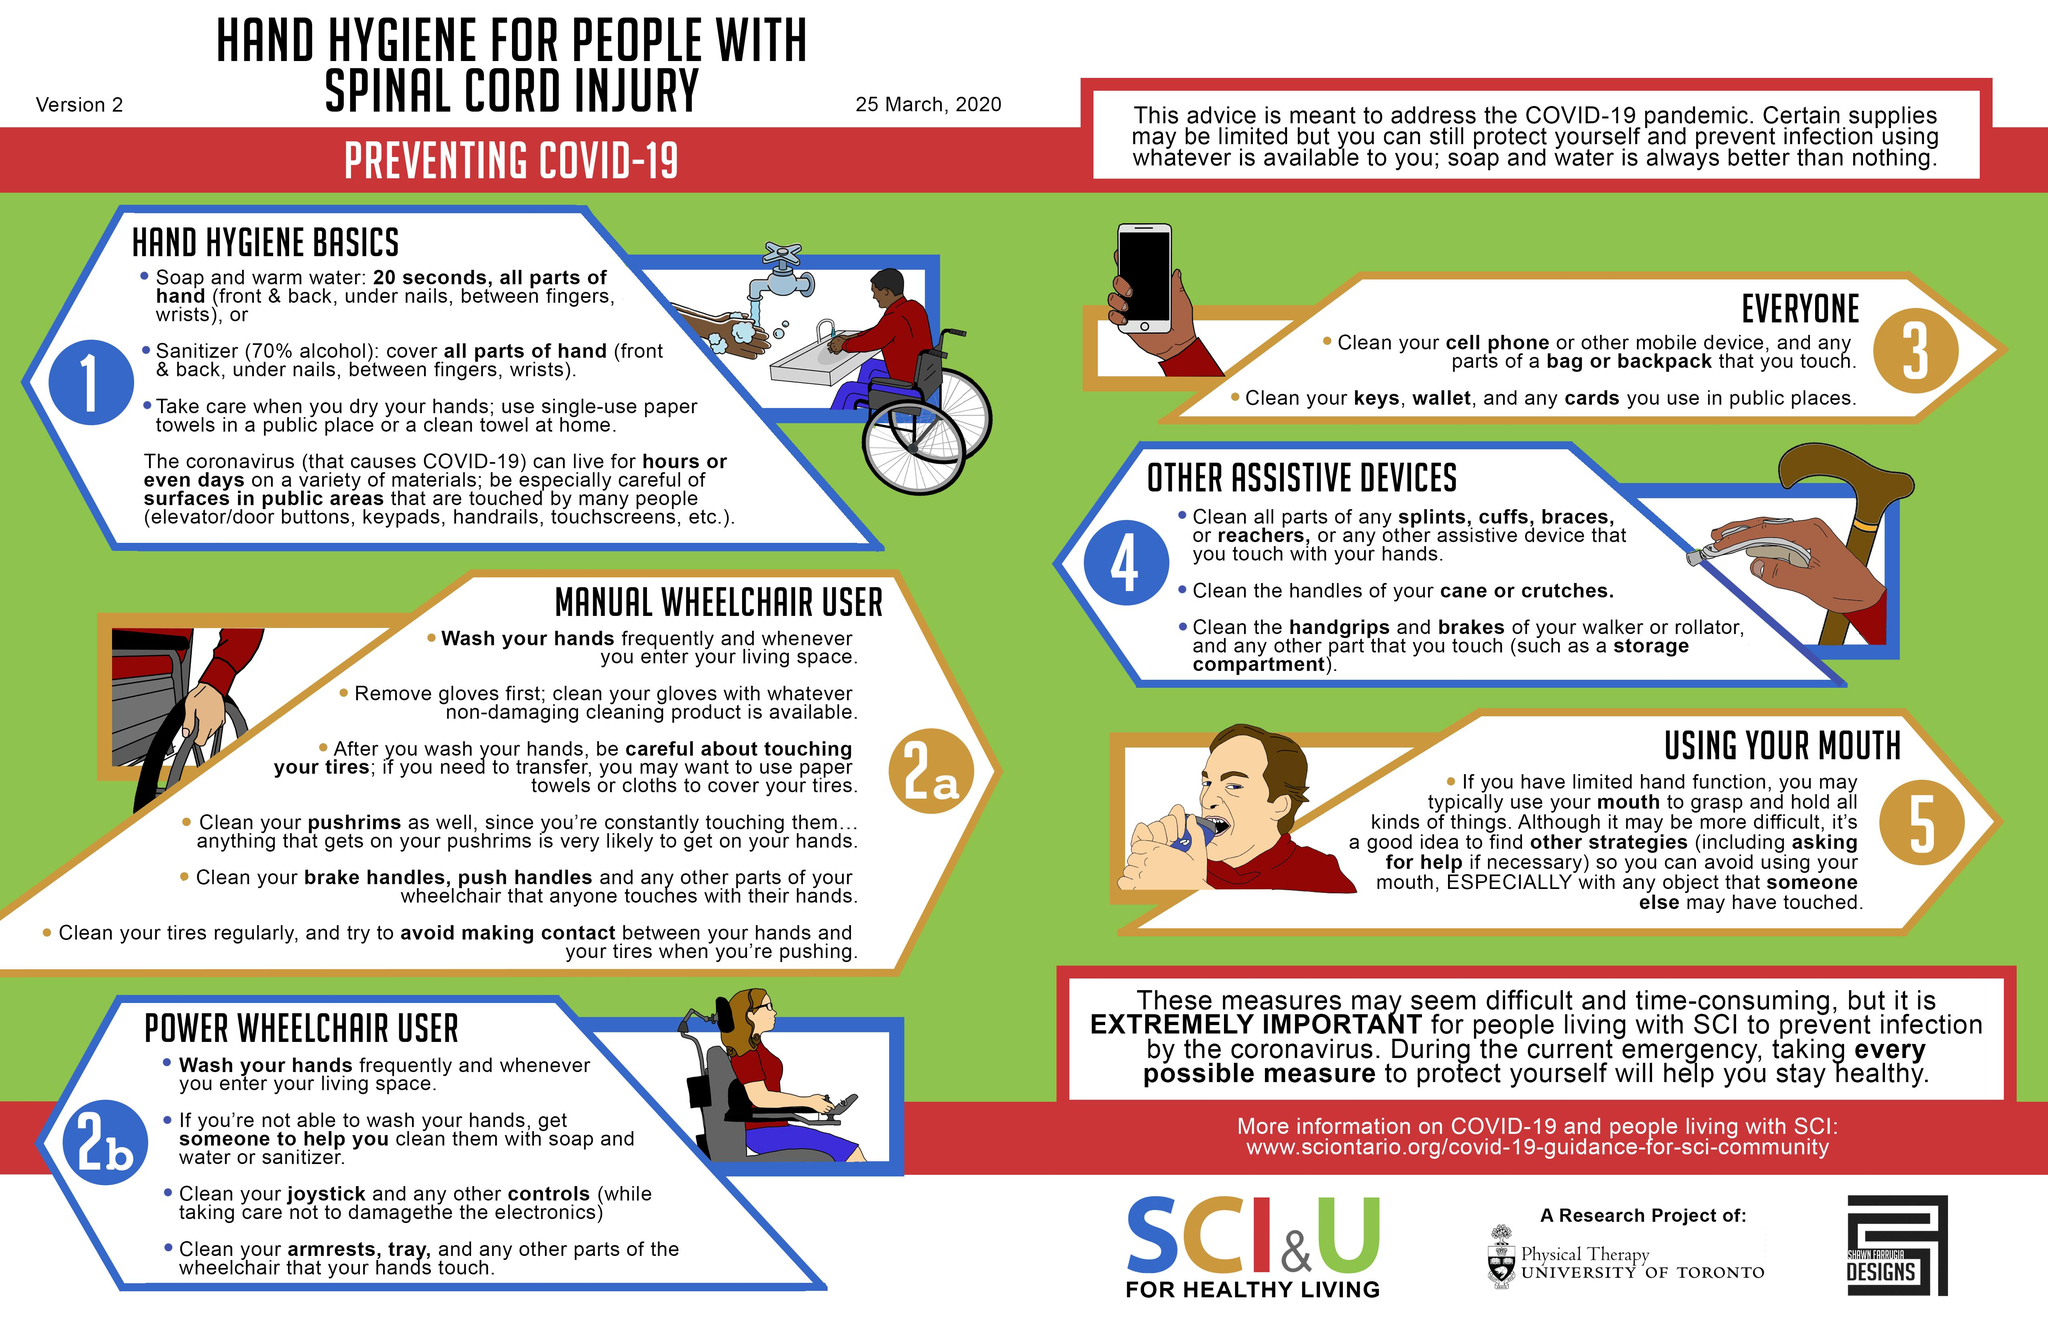Point out several critical features in this image. How many bullet points are there under "other assistive devices"? There are 3 of them. The power wheelchair contains electronic components that require regular cleaning, specifically the joystick and control buttons. It is recommended to use a sanitizer instead of soap and warm water according to the instructions. In public areas, it is crucial to consider the common surfaces such as elevator/door buttons, keypads, handrails, and touchscreens that may contain germs and bacteria, and implement effective cleaning and disinfection protocols to minimize the risk of illness transmission. It is important to carefully clean the front and back of the hand, as well as under the nails, between the fingers, and on the wrists, with sanitizer to ensure proper hygiene. 